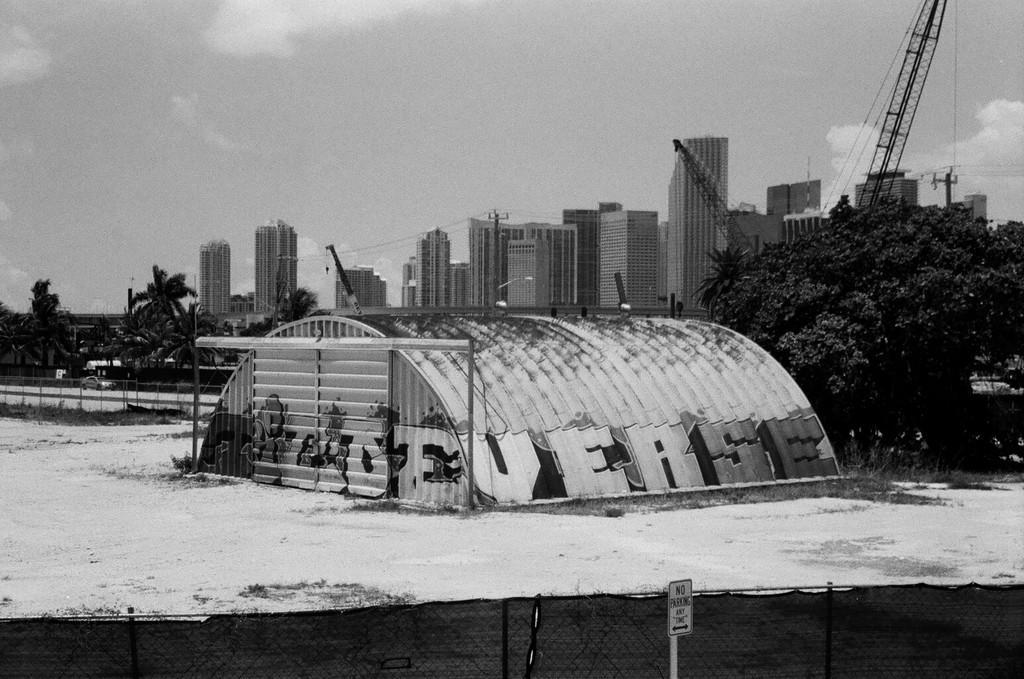Please provide a concise description of this image. In this image we can see a house on the ice, fence and the signboard. On the right side we can see a tree, crane, buildings, grass, utility poles with wires. On the left side we can see a car on the road, a fence, trees and the sky which looks cloudy. 